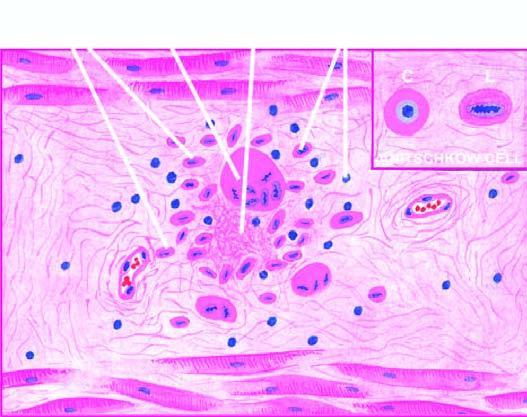what shows anitschkow cell in longitudinal section with caterpillar-like serrated nuclear chromatin, while cross section cs shows owl-eye appearance of central chromatin mass and perinuclear halo?
Answer the question using a single word or phrase. Inbox 